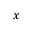Convert formula to latex. <formula><loc_0><loc_0><loc_500><loc_500>x</formula> 